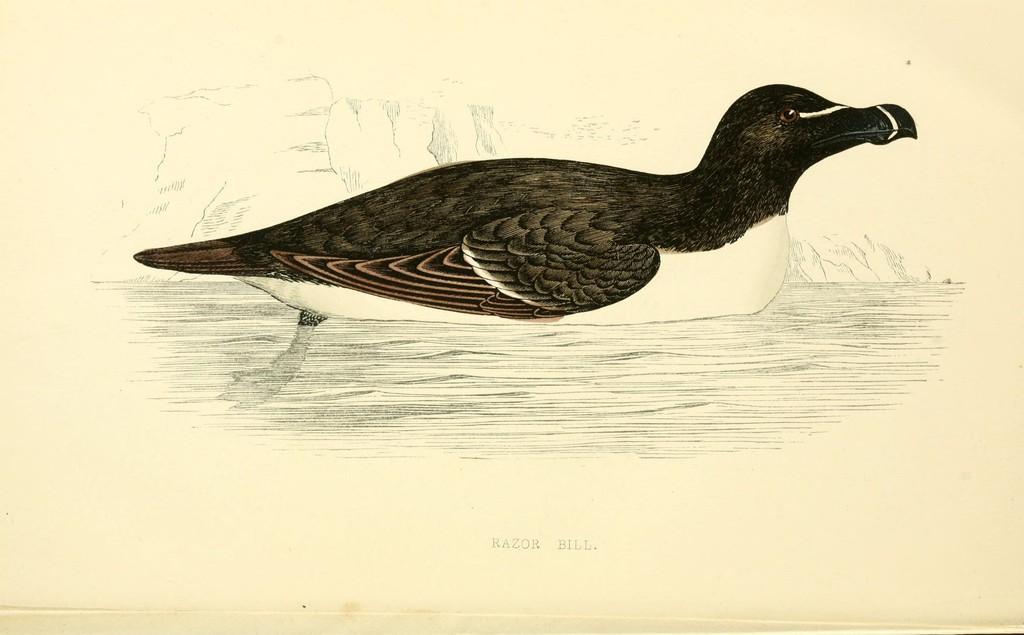Please provide a concise description of this image. In this picture, I see a duck in the water and text at the bottom of the picture and the picture looks like a art. 